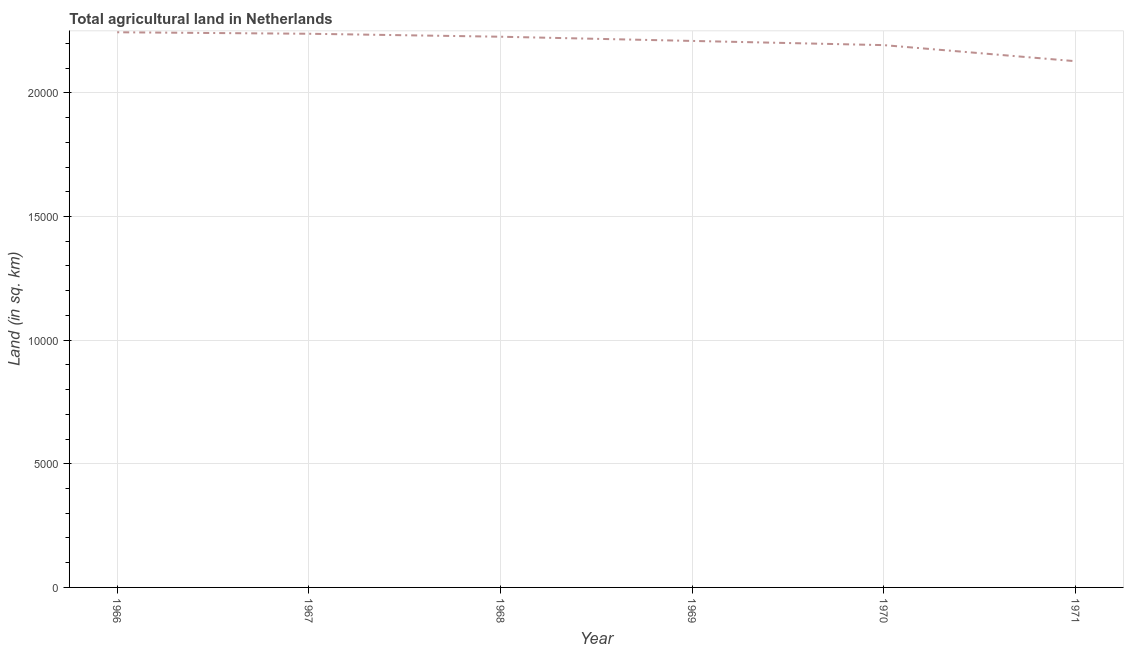What is the agricultural land in 1971?
Your response must be concise. 2.13e+04. Across all years, what is the maximum agricultural land?
Keep it short and to the point. 2.24e+04. Across all years, what is the minimum agricultural land?
Offer a very short reply. 2.13e+04. In which year was the agricultural land maximum?
Provide a succinct answer. 1966. In which year was the agricultural land minimum?
Keep it short and to the point. 1971. What is the sum of the agricultural land?
Give a very brief answer. 1.32e+05. What is the difference between the agricultural land in 1967 and 1970?
Your answer should be very brief. 460. What is the average agricultural land per year?
Ensure brevity in your answer.  2.21e+04. What is the median agricultural land?
Give a very brief answer. 2.22e+04. In how many years, is the agricultural land greater than 18000 sq. km?
Offer a terse response. 6. What is the ratio of the agricultural land in 1968 to that in 1971?
Your answer should be compact. 1.05. Is the difference between the agricultural land in 1968 and 1971 greater than the difference between any two years?
Offer a terse response. No. Is the sum of the agricultural land in 1970 and 1971 greater than the maximum agricultural land across all years?
Make the answer very short. Yes. What is the difference between the highest and the lowest agricultural land?
Give a very brief answer. 1170. How many lines are there?
Ensure brevity in your answer.  1. What is the difference between two consecutive major ticks on the Y-axis?
Ensure brevity in your answer.  5000. What is the title of the graph?
Your answer should be very brief. Total agricultural land in Netherlands. What is the label or title of the Y-axis?
Make the answer very short. Land (in sq. km). What is the Land (in sq. km) in 1966?
Your response must be concise. 2.24e+04. What is the Land (in sq. km) of 1967?
Give a very brief answer. 2.24e+04. What is the Land (in sq. km) of 1968?
Keep it short and to the point. 2.23e+04. What is the Land (in sq. km) of 1969?
Keep it short and to the point. 2.21e+04. What is the Land (in sq. km) in 1970?
Make the answer very short. 2.19e+04. What is the Land (in sq. km) of 1971?
Provide a succinct answer. 2.13e+04. What is the difference between the Land (in sq. km) in 1966 and 1967?
Provide a succinct answer. 60. What is the difference between the Land (in sq. km) in 1966 and 1968?
Provide a short and direct response. 180. What is the difference between the Land (in sq. km) in 1966 and 1969?
Your response must be concise. 350. What is the difference between the Land (in sq. km) in 1966 and 1970?
Keep it short and to the point. 520. What is the difference between the Land (in sq. km) in 1966 and 1971?
Offer a very short reply. 1170. What is the difference between the Land (in sq. km) in 1967 and 1968?
Offer a very short reply. 120. What is the difference between the Land (in sq. km) in 1967 and 1969?
Your answer should be very brief. 290. What is the difference between the Land (in sq. km) in 1967 and 1970?
Provide a succinct answer. 460. What is the difference between the Land (in sq. km) in 1967 and 1971?
Your answer should be compact. 1110. What is the difference between the Land (in sq. km) in 1968 and 1969?
Provide a short and direct response. 170. What is the difference between the Land (in sq. km) in 1968 and 1970?
Offer a very short reply. 340. What is the difference between the Land (in sq. km) in 1968 and 1971?
Give a very brief answer. 990. What is the difference between the Land (in sq. km) in 1969 and 1970?
Your answer should be very brief. 170. What is the difference between the Land (in sq. km) in 1969 and 1971?
Provide a succinct answer. 820. What is the difference between the Land (in sq. km) in 1970 and 1971?
Offer a terse response. 650. What is the ratio of the Land (in sq. km) in 1966 to that in 1967?
Provide a short and direct response. 1. What is the ratio of the Land (in sq. km) in 1966 to that in 1968?
Ensure brevity in your answer.  1.01. What is the ratio of the Land (in sq. km) in 1966 to that in 1969?
Give a very brief answer. 1.02. What is the ratio of the Land (in sq. km) in 1966 to that in 1970?
Keep it short and to the point. 1.02. What is the ratio of the Land (in sq. km) in 1966 to that in 1971?
Make the answer very short. 1.05. What is the ratio of the Land (in sq. km) in 1967 to that in 1970?
Provide a short and direct response. 1.02. What is the ratio of the Land (in sq. km) in 1967 to that in 1971?
Provide a short and direct response. 1.05. What is the ratio of the Land (in sq. km) in 1968 to that in 1971?
Offer a very short reply. 1.05. What is the ratio of the Land (in sq. km) in 1969 to that in 1970?
Your response must be concise. 1.01. What is the ratio of the Land (in sq. km) in 1969 to that in 1971?
Give a very brief answer. 1.04. What is the ratio of the Land (in sq. km) in 1970 to that in 1971?
Ensure brevity in your answer.  1.03. 